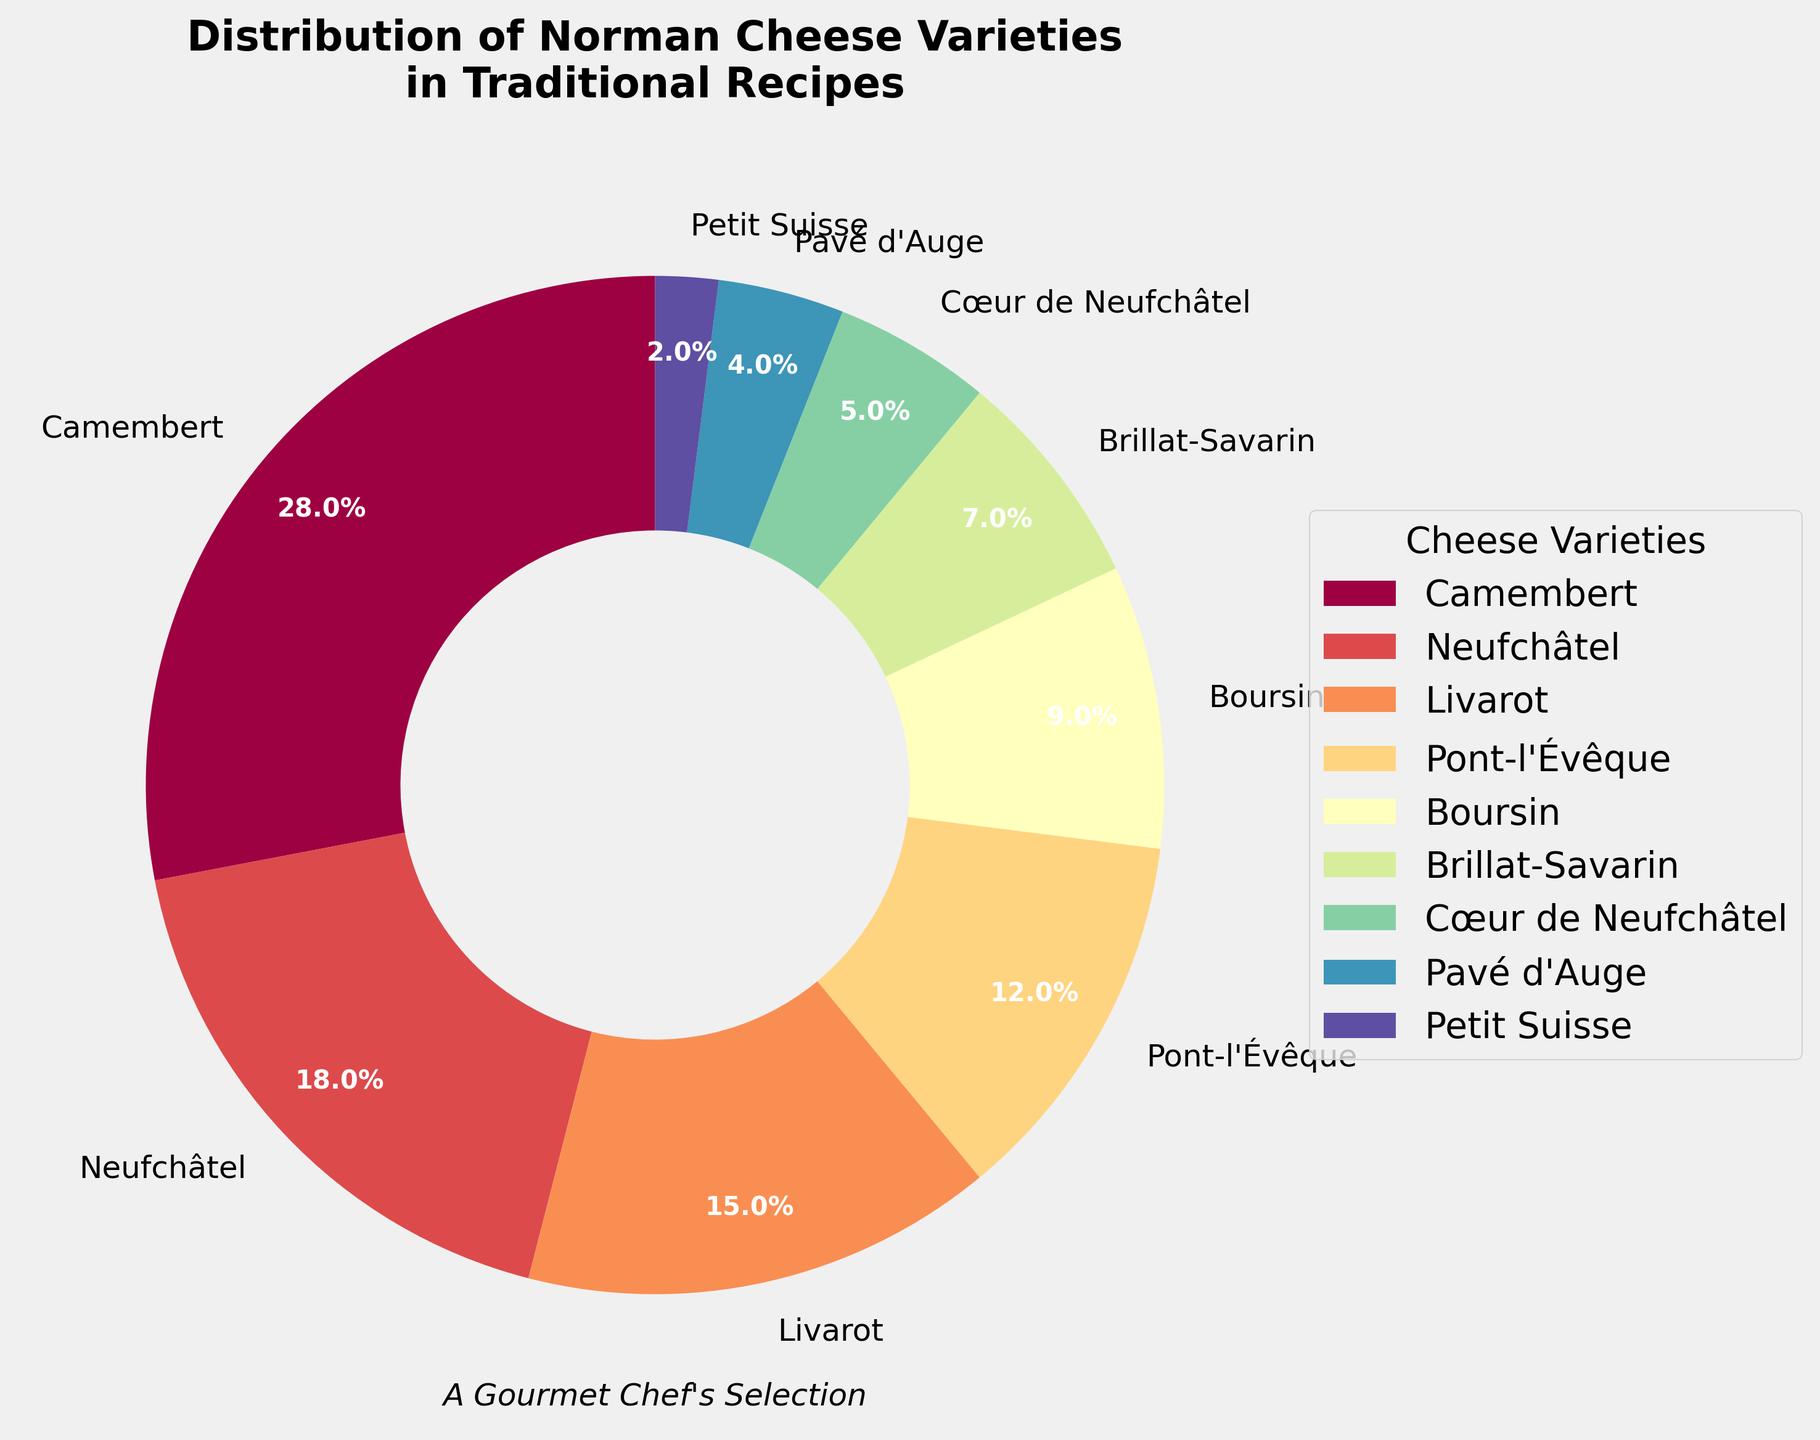Which cheese variety represents the largest portion in the pie chart? Among the cheese varieties displayed, identify the one with the highest percentage, which is 28%.
Answer: Camembert What is the combined percentage of Neufchâtel and Cœur de Neufchâtel? Sum the percentages of Neufchâtel (18%) and Cœur de Neufchâtel (5%). 18 + 5 = 23
Answer: 23% Which two cheese varieties have the smallest contributions to the chart? Identify the varieties with the lowest percentages, which are Petit Suisse (2%) and Pavé d'Auge (4%).
Answer: Petit Suisse and Pavé d'Auge Is the percentage of Brillat-Savarin greater than that of Cœur de Neufchâtel? Compare the percentages of Brillat-Savarin (7%) and Cœur de Neufchâtel (5%). 7% > 5%, so yes.
Answer: Yes How much more is the percentage of Livarot compared to Boursin? Subtract the percentage of Boursin (9%) from Livarot (15%). 15 - 9 = 6
Answer: 6% Which color in the pie chart represents Pont-l'Évêque? Since the chart uses a custom color palette, but without displaying the chart, a viewer can only infer that each label is next to its respective wedge/color, Pont-l'Évêque is 12%.
Answer: Unable to determine color without visual What is the total percentage represented by Camembert, Neufchâtel, and Livarot combined? Sum the percentages of Camembert (28%), Neufchâtel (18%), and Livarot (15%). 28 + 18 + 15 = 61
Answer: 61% Which has a higher percentage, the combined total of Pont-l'Évêque and Boursin, or Camembert alone? Calculate the sum of Pont-l'Évêque (12%) and Boursin (9%), giving 21%. Compare this to Camembert's 28%. 21% < 28%
Answer: Camembert alone What is the difference in percentage between the top two cheese varieties? Identify the top two percentages (Camembert at 28% and Neufchâtel at 18%) and subtract the second from the top. 28 - 18 = 10
Answer: 10% What is the combined percentage of all varieties that contribute less than 10% each? Identify varieties under 10% (Brillat-Savarin 7%, Cœur de Neufchâtel 5%, Pavé d'Auge 4%, Petit Suisse 2%) and sum their percentages. 7 + 5 + 4 + 2 = 18
Answer: 18% 